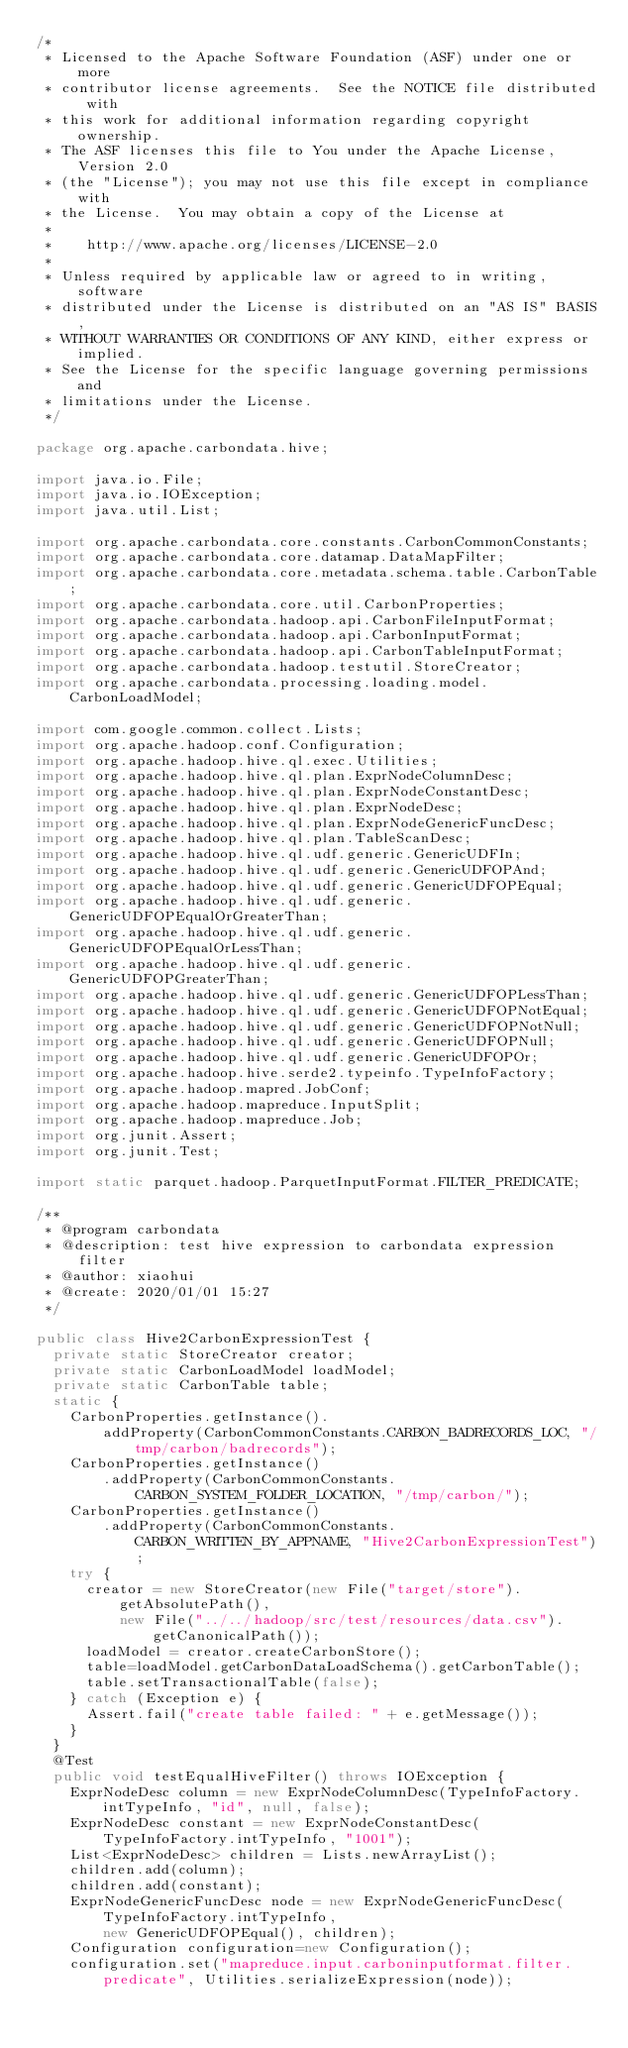Convert code to text. <code><loc_0><loc_0><loc_500><loc_500><_Java_>/*
 * Licensed to the Apache Software Foundation (ASF) under one or more
 * contributor license agreements.  See the NOTICE file distributed with
 * this work for additional information regarding copyright ownership.
 * The ASF licenses this file to You under the Apache License, Version 2.0
 * (the "License"); you may not use this file except in compliance with
 * the License.  You may obtain a copy of the License at
 *
 *    http://www.apache.org/licenses/LICENSE-2.0
 *
 * Unless required by applicable law or agreed to in writing, software
 * distributed under the License is distributed on an "AS IS" BASIS,
 * WITHOUT WARRANTIES OR CONDITIONS OF ANY KIND, either express or implied.
 * See the License for the specific language governing permissions and
 * limitations under the License.
 */

package org.apache.carbondata.hive;

import java.io.File;
import java.io.IOException;
import java.util.List;

import org.apache.carbondata.core.constants.CarbonCommonConstants;
import org.apache.carbondata.core.datamap.DataMapFilter;
import org.apache.carbondata.core.metadata.schema.table.CarbonTable;
import org.apache.carbondata.core.util.CarbonProperties;
import org.apache.carbondata.hadoop.api.CarbonFileInputFormat;
import org.apache.carbondata.hadoop.api.CarbonInputFormat;
import org.apache.carbondata.hadoop.api.CarbonTableInputFormat;
import org.apache.carbondata.hadoop.testutil.StoreCreator;
import org.apache.carbondata.processing.loading.model.CarbonLoadModel;

import com.google.common.collect.Lists;
import org.apache.hadoop.conf.Configuration;
import org.apache.hadoop.hive.ql.exec.Utilities;
import org.apache.hadoop.hive.ql.plan.ExprNodeColumnDesc;
import org.apache.hadoop.hive.ql.plan.ExprNodeConstantDesc;
import org.apache.hadoop.hive.ql.plan.ExprNodeDesc;
import org.apache.hadoop.hive.ql.plan.ExprNodeGenericFuncDesc;
import org.apache.hadoop.hive.ql.plan.TableScanDesc;
import org.apache.hadoop.hive.ql.udf.generic.GenericUDFIn;
import org.apache.hadoop.hive.ql.udf.generic.GenericUDFOPAnd;
import org.apache.hadoop.hive.ql.udf.generic.GenericUDFOPEqual;
import org.apache.hadoop.hive.ql.udf.generic.GenericUDFOPEqualOrGreaterThan;
import org.apache.hadoop.hive.ql.udf.generic.GenericUDFOPEqualOrLessThan;
import org.apache.hadoop.hive.ql.udf.generic.GenericUDFOPGreaterThan;
import org.apache.hadoop.hive.ql.udf.generic.GenericUDFOPLessThan;
import org.apache.hadoop.hive.ql.udf.generic.GenericUDFOPNotEqual;
import org.apache.hadoop.hive.ql.udf.generic.GenericUDFOPNotNull;
import org.apache.hadoop.hive.ql.udf.generic.GenericUDFOPNull;
import org.apache.hadoop.hive.ql.udf.generic.GenericUDFOPOr;
import org.apache.hadoop.hive.serde2.typeinfo.TypeInfoFactory;
import org.apache.hadoop.mapred.JobConf;
import org.apache.hadoop.mapreduce.InputSplit;
import org.apache.hadoop.mapreduce.Job;
import org.junit.Assert;
import org.junit.Test;

import static parquet.hadoop.ParquetInputFormat.FILTER_PREDICATE;

/**
 * @program carbondata
 * @description: test hive expression to carbondata expression filter
 * @author: xiaohui
 * @create: 2020/01/01 15:27
 */

public class Hive2CarbonExpressionTest {
  private static StoreCreator creator;
  private static CarbonLoadModel loadModel;
  private static CarbonTable table;
  static {
    CarbonProperties.getInstance().
        addProperty(CarbonCommonConstants.CARBON_BADRECORDS_LOC, "/tmp/carbon/badrecords");
    CarbonProperties.getInstance()
        .addProperty(CarbonCommonConstants.CARBON_SYSTEM_FOLDER_LOCATION, "/tmp/carbon/");
    CarbonProperties.getInstance()
        .addProperty(CarbonCommonConstants.CARBON_WRITTEN_BY_APPNAME, "Hive2CarbonExpressionTest");
    try {
      creator = new StoreCreator(new File("target/store").getAbsolutePath(),
          new File("../../hadoop/src/test/resources/data.csv").getCanonicalPath());
      loadModel = creator.createCarbonStore();
      table=loadModel.getCarbonDataLoadSchema().getCarbonTable();
      table.setTransactionalTable(false);
    } catch (Exception e) {
      Assert.fail("create table failed: " + e.getMessage());
    }
  }
  @Test
  public void testEqualHiveFilter() throws IOException {
    ExprNodeDesc column = new ExprNodeColumnDesc(TypeInfoFactory.intTypeInfo, "id", null, false);
    ExprNodeDesc constant = new ExprNodeConstantDesc(TypeInfoFactory.intTypeInfo, "1001");
    List<ExprNodeDesc> children = Lists.newArrayList();
    children.add(column);
    children.add(constant);
    ExprNodeGenericFuncDesc node = new ExprNodeGenericFuncDesc(TypeInfoFactory.intTypeInfo,
        new GenericUDFOPEqual(), children);
    Configuration configuration=new Configuration();
    configuration.set("mapreduce.input.carboninputformat.filter.predicate", Utilities.serializeExpression(node));</code> 